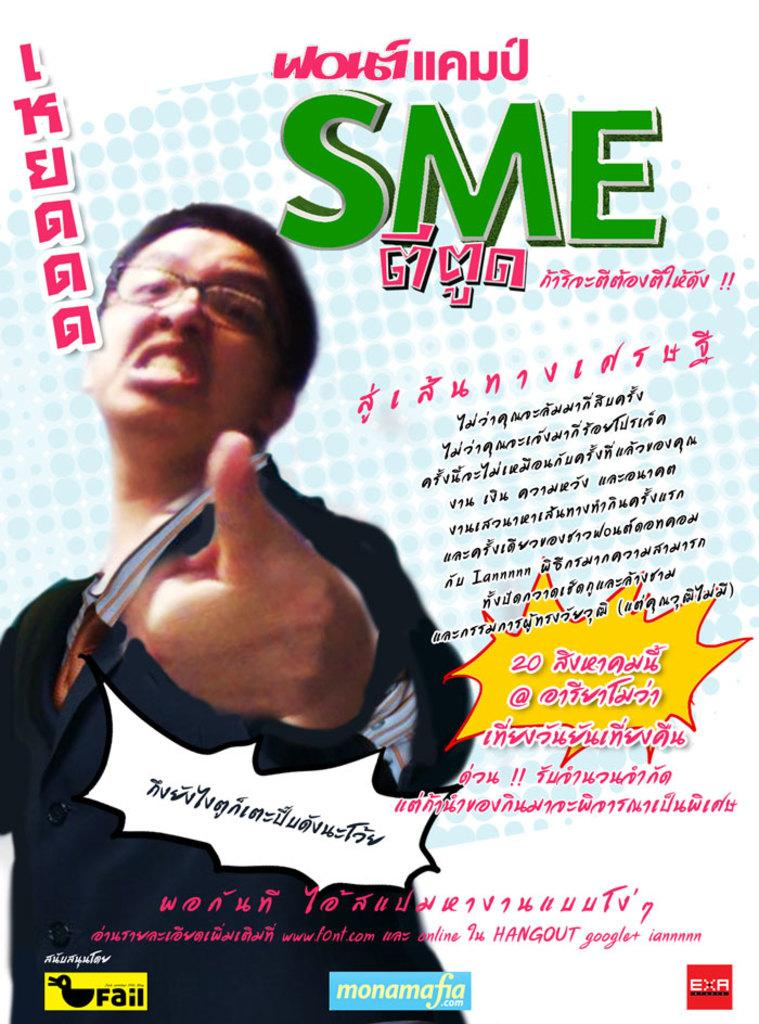What can be said about the nature of the image? The image is edited. Where is the man located in the image? The man is on the left side of the image. What is the man doing with his finger? The man is showing his finger. How does the man appear to be feeling? The man appears to be angry. What accessories is the man wearing? The man is wearing spectacles, a coat, and a tie. What is present on the right side of the image? There is a matter on the right side of the image. How many clovers can be seen growing on the man's tie in the image? There are no clovers visible on the man's tie in the image. Can you describe the stranger standing next to the man in the image? There is no stranger present in the image; only the man and the matter on the right side are visible. 